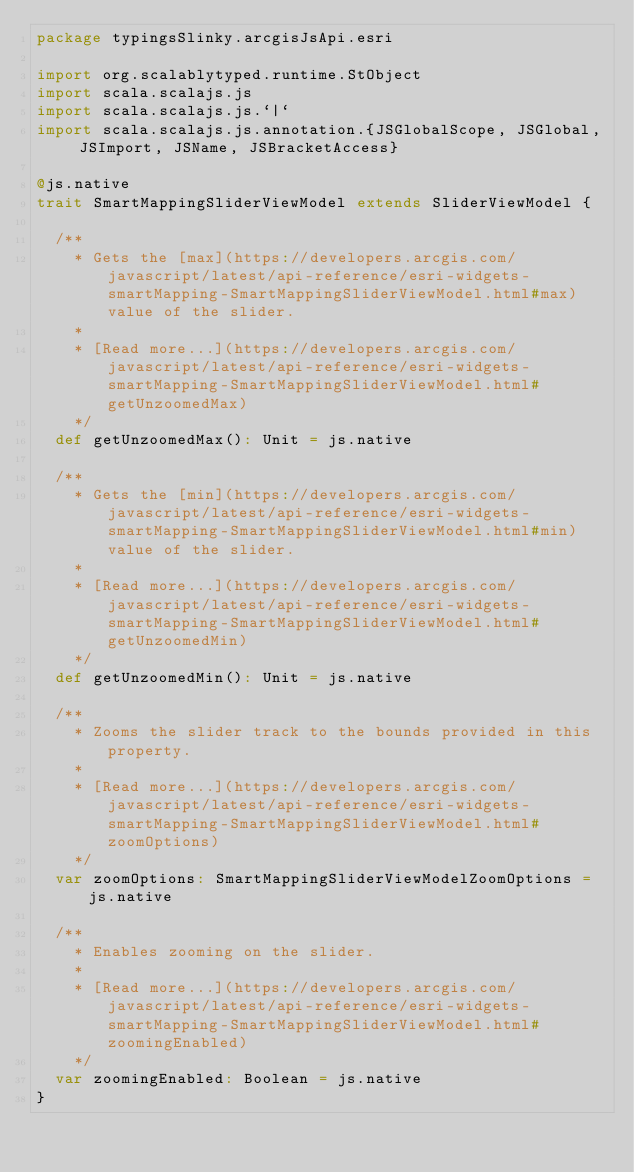Convert code to text. <code><loc_0><loc_0><loc_500><loc_500><_Scala_>package typingsSlinky.arcgisJsApi.esri

import org.scalablytyped.runtime.StObject
import scala.scalajs.js
import scala.scalajs.js.`|`
import scala.scalajs.js.annotation.{JSGlobalScope, JSGlobal, JSImport, JSName, JSBracketAccess}

@js.native
trait SmartMappingSliderViewModel extends SliderViewModel {
  
  /**
    * Gets the [max](https://developers.arcgis.com/javascript/latest/api-reference/esri-widgets-smartMapping-SmartMappingSliderViewModel.html#max) value of the slider.
    *
    * [Read more...](https://developers.arcgis.com/javascript/latest/api-reference/esri-widgets-smartMapping-SmartMappingSliderViewModel.html#getUnzoomedMax)
    */
  def getUnzoomedMax(): Unit = js.native
  
  /**
    * Gets the [min](https://developers.arcgis.com/javascript/latest/api-reference/esri-widgets-smartMapping-SmartMappingSliderViewModel.html#min) value of the slider.
    *
    * [Read more...](https://developers.arcgis.com/javascript/latest/api-reference/esri-widgets-smartMapping-SmartMappingSliderViewModel.html#getUnzoomedMin)
    */
  def getUnzoomedMin(): Unit = js.native
  
  /**
    * Zooms the slider track to the bounds provided in this property.
    *
    * [Read more...](https://developers.arcgis.com/javascript/latest/api-reference/esri-widgets-smartMapping-SmartMappingSliderViewModel.html#zoomOptions)
    */
  var zoomOptions: SmartMappingSliderViewModelZoomOptions = js.native
  
  /**
    * Enables zooming on the slider.
    *
    * [Read more...](https://developers.arcgis.com/javascript/latest/api-reference/esri-widgets-smartMapping-SmartMappingSliderViewModel.html#zoomingEnabled)
    */
  var zoomingEnabled: Boolean = js.native
}
</code> 